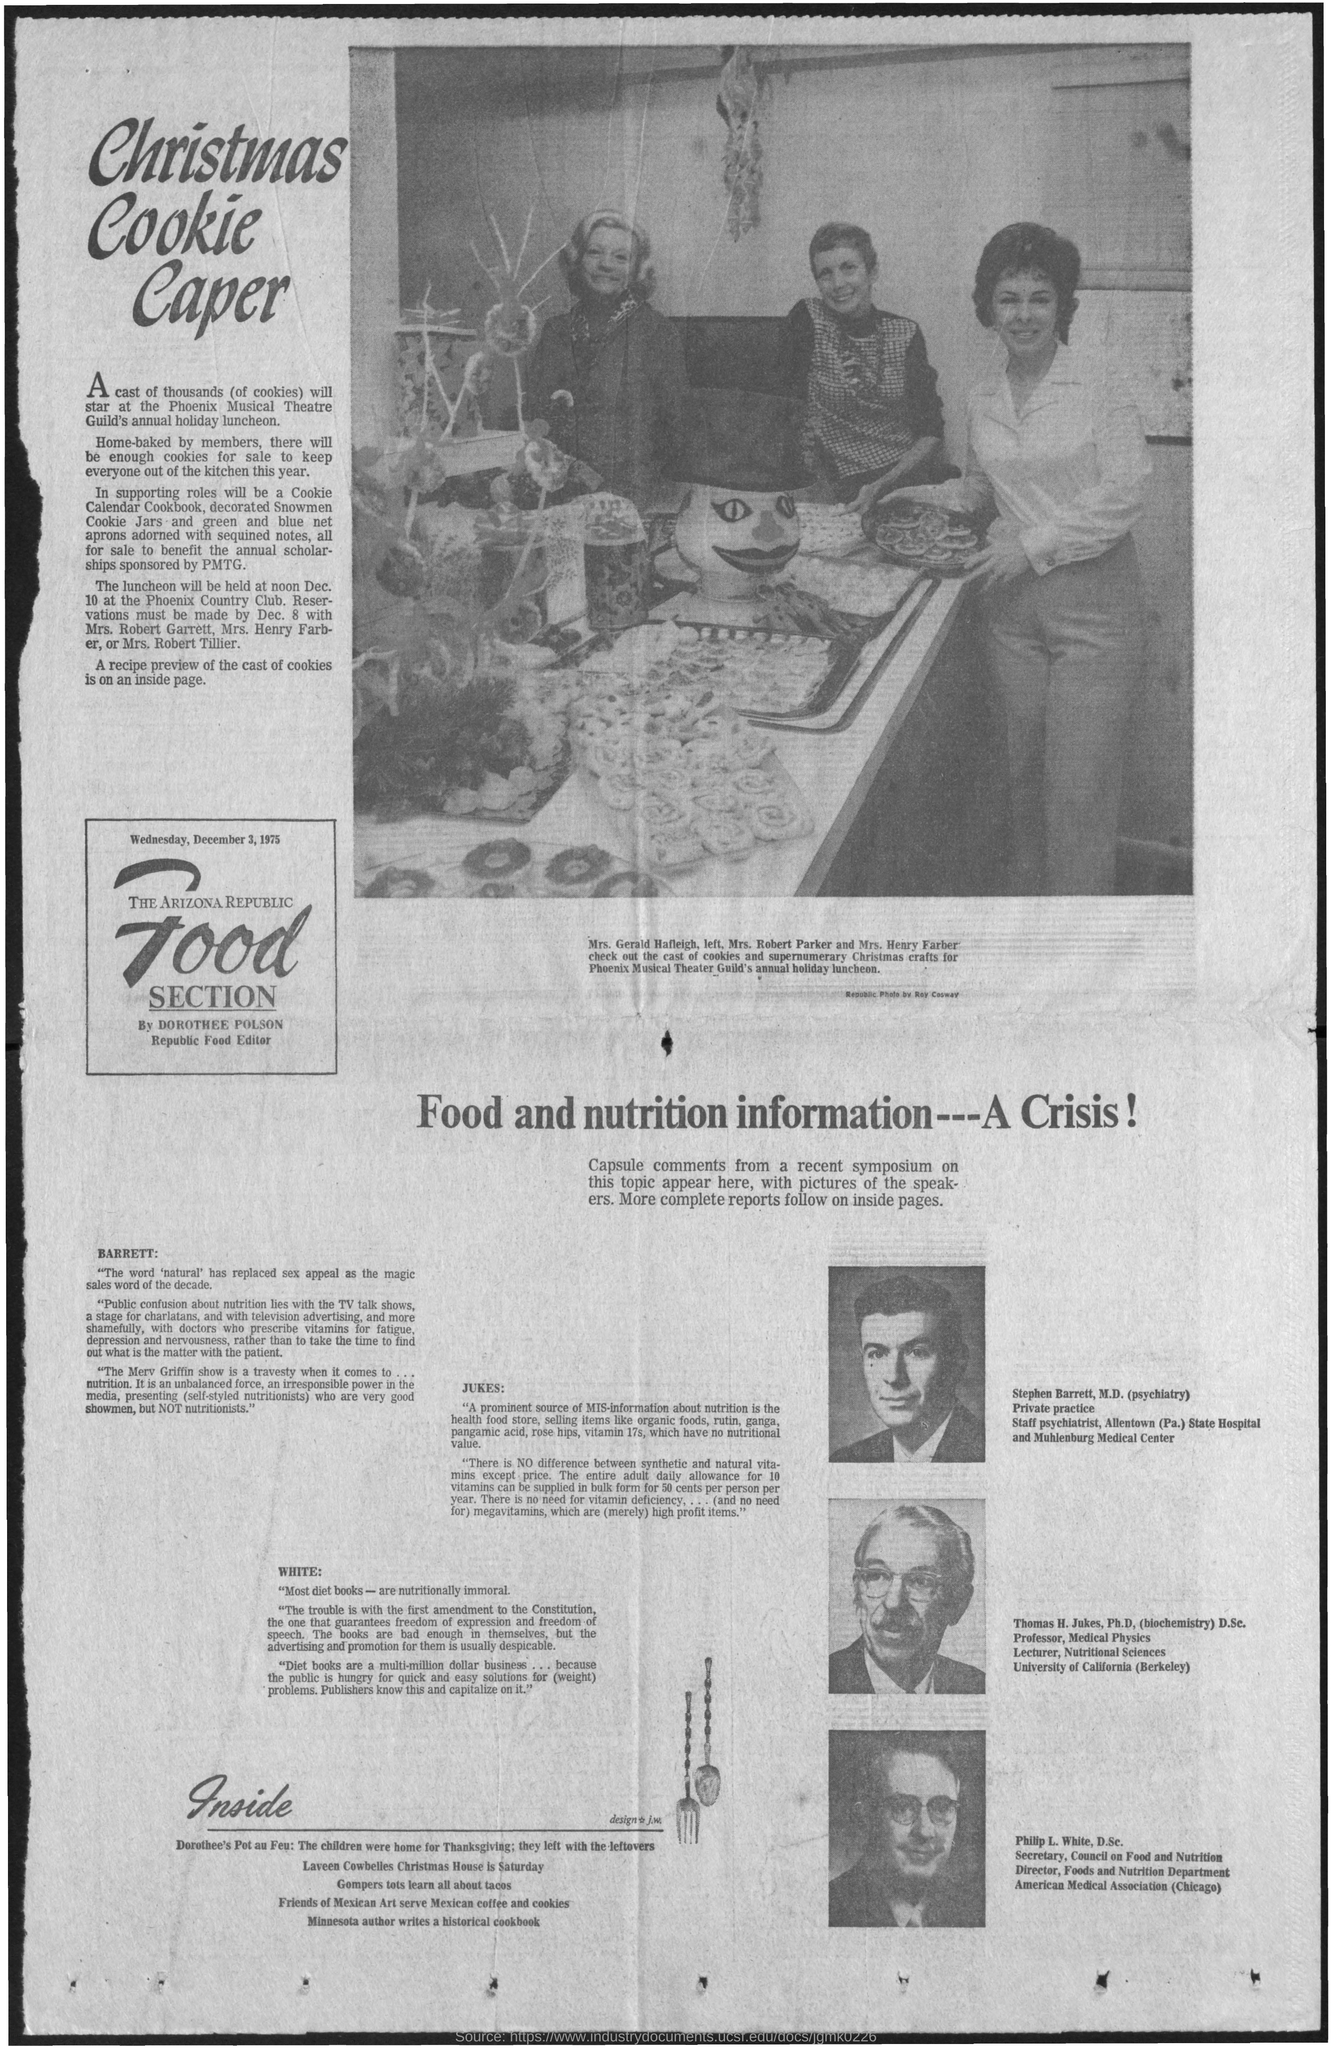Draw attention to some important aspects in this diagram. The Phoenix Musical Theatre Guild held its annual holiday luncheon on December 10th at noon. The Phoenix Musical Theatre Guild held its annual holiday luncheon at the Phoenix Country Club. 